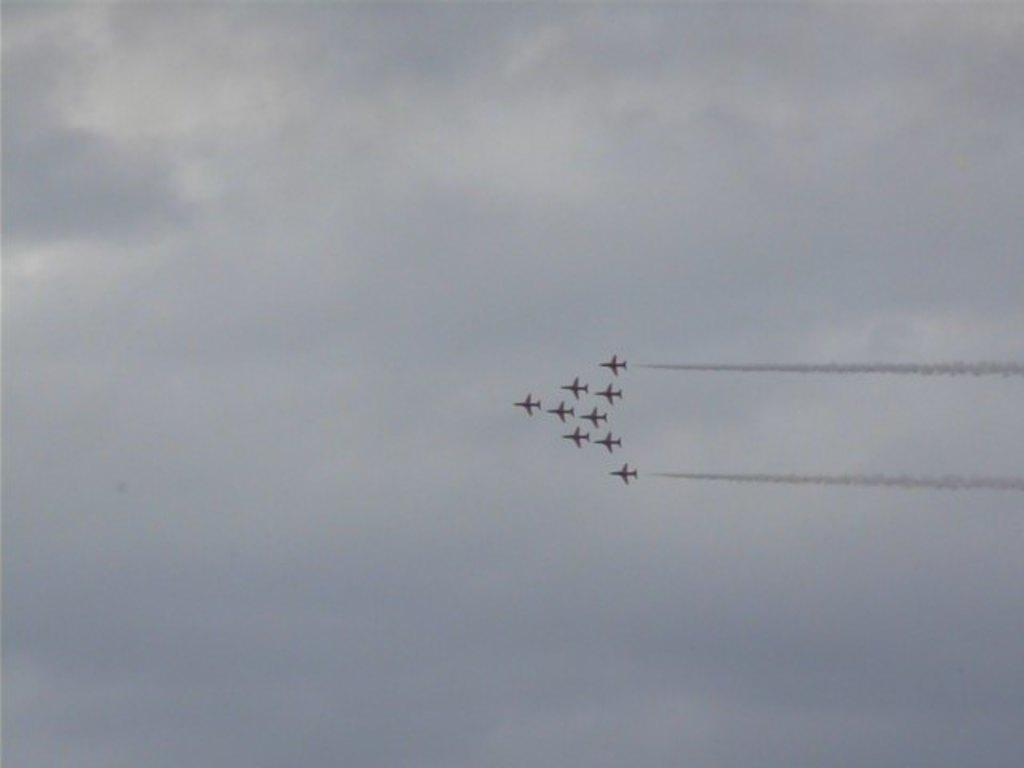What is happening in the sky in the image? There are planes flying in the air. What is the weather like in the image? The sky is cloudy. What type of knife is being used by the partner while driving in the image? There is no partner or driving present in the image, and therefore no knife can be observed. 